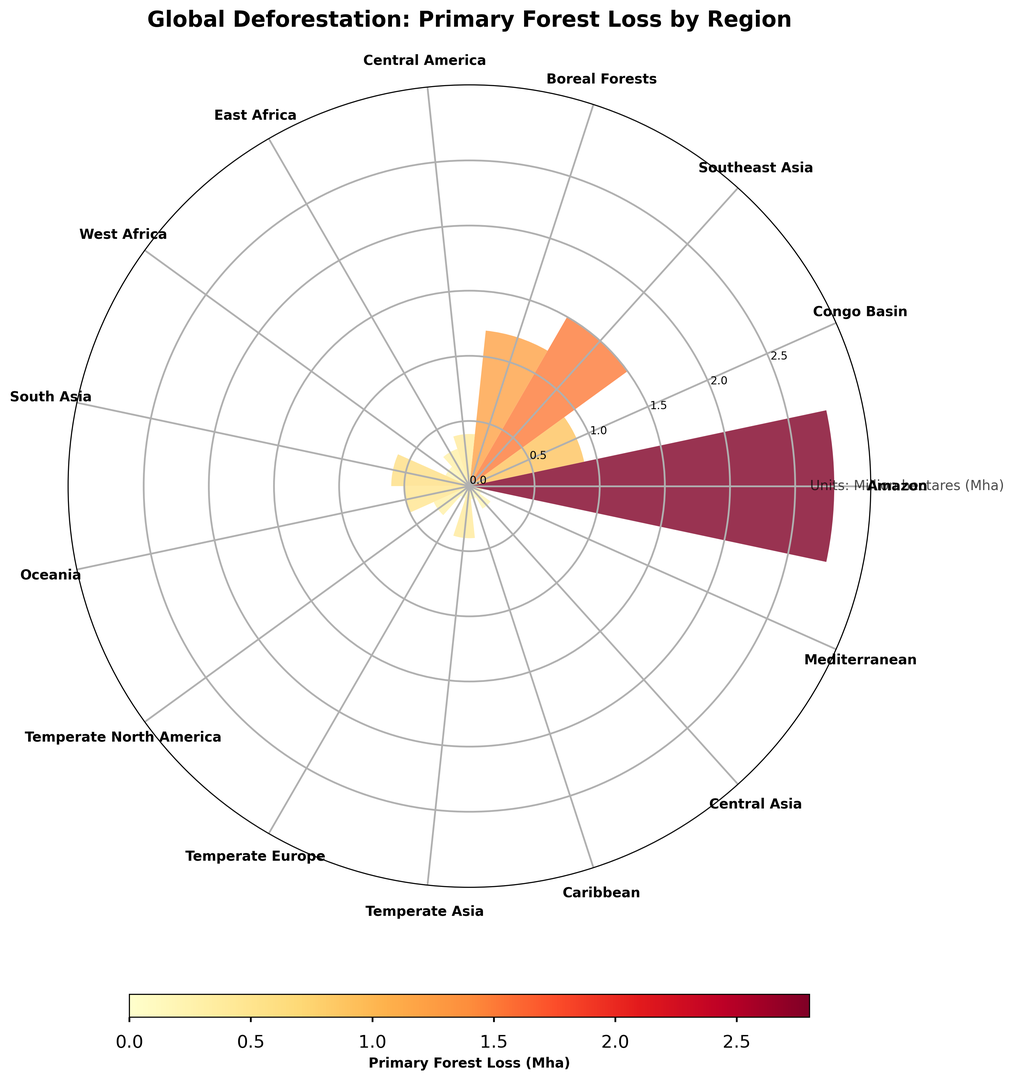How much more primary forest loss did the Amazon region experience compared to the Congo Basin? The Amazon experienced a primary forest loss of 2.8 Mha, while the Congo Basin had 0.9 Mha. The difference between them is 2.8 - 0.9 which equals 1.9 Mha.
Answer: 1.9 Mha Which region had the highest primary forest loss, and what was the quantity? By observing the height of the bars, the Amazon region has the highest primary forest loss at 2.8 Mha.
Answer: Amazon, 2.8 Mha Which regions had primary forest losses greater than 1 Mha? The regions with bars taller than 1 Mha are the Amazon (2.8 Mha), Southeast Asia (1.5 Mha), and Boreal Forests (1.2 Mha).
Answer: Amazon, Southeast Asia, Boreal Forests Of the regions with the lowest primary forest losses, which ones are below 0.3 Mha? By looking at the shortest bars, the regions with primary forest loss below 0.3 Mha are West Africa (0.2 Mha), Temperate Europe (0.1 Mha), Caribbean (0.1 Mha), and Mediterranean (0.1 Mha).
Answer: West Africa, Temperate Europe, Caribbean, Mediterranean Which regions have a primary forest loss equal to 0.4 Mha? Observe the bars that reach up to the 0.4 Mha tick mark. The regions are Central America and Temperate Asia.
Answer: Central America, Temperate Asia What is the average primary forest loss across all the displayed regions? Sum the primary forest losses: 2.8 + 0.9 + 1.5 + 1.2 + 0.4 + 0.3 + 0.2 + 0.6 + 0.5 + 0.3 + 0.1 + 0.4 + 0.1 + 0.2 + 0.1 = 9.6 Mha. There are 15 regions, so the average is 9.6 / 15 = 0.64 Mha.
Answer: 0.64 Mha How does the primary forest loss of Boreal Forests compare to Southeast Asia? Boreal Forests had a primary forest loss of 1.2 Mha, while Southeast Asia had 1.5 Mha. Therefore, Southeast Asia had 0.3 Mha more primary forest loss than Boreal Forests (1.5 - 1.2).
Answer: Southeast Asia by 0.3 Mha Which regions show a primary forest loss of 0.5 Mha or more? Look for bars with a height of 0.5 Mha or above. These regions are Amazon (2.8 Mha), Congo Basin (0.9 Mha), Southeast Asia (1.5 Mha), Boreal Forests (1.2 Mha), South Asia (0.6 Mha), and Oceania (0.5 Mha).
Answer: Amazon, Congo Basin, Southeast Asia, Boreal Forests, South Asia, Oceania 